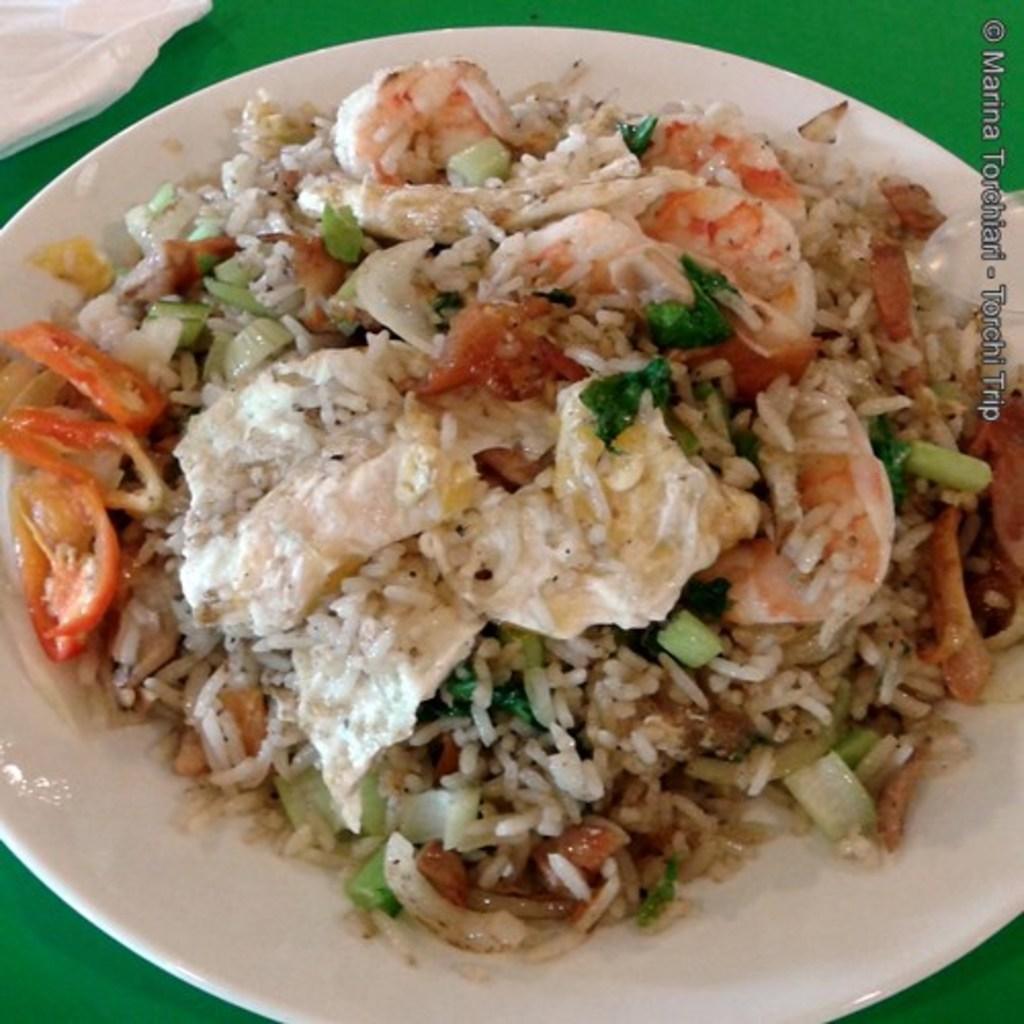Can you describe this image briefly? In this image we can see a plate containing food and spoon placed on the surface. At the top of the image we can see a cloth. On the left side of the image we can see some text. 